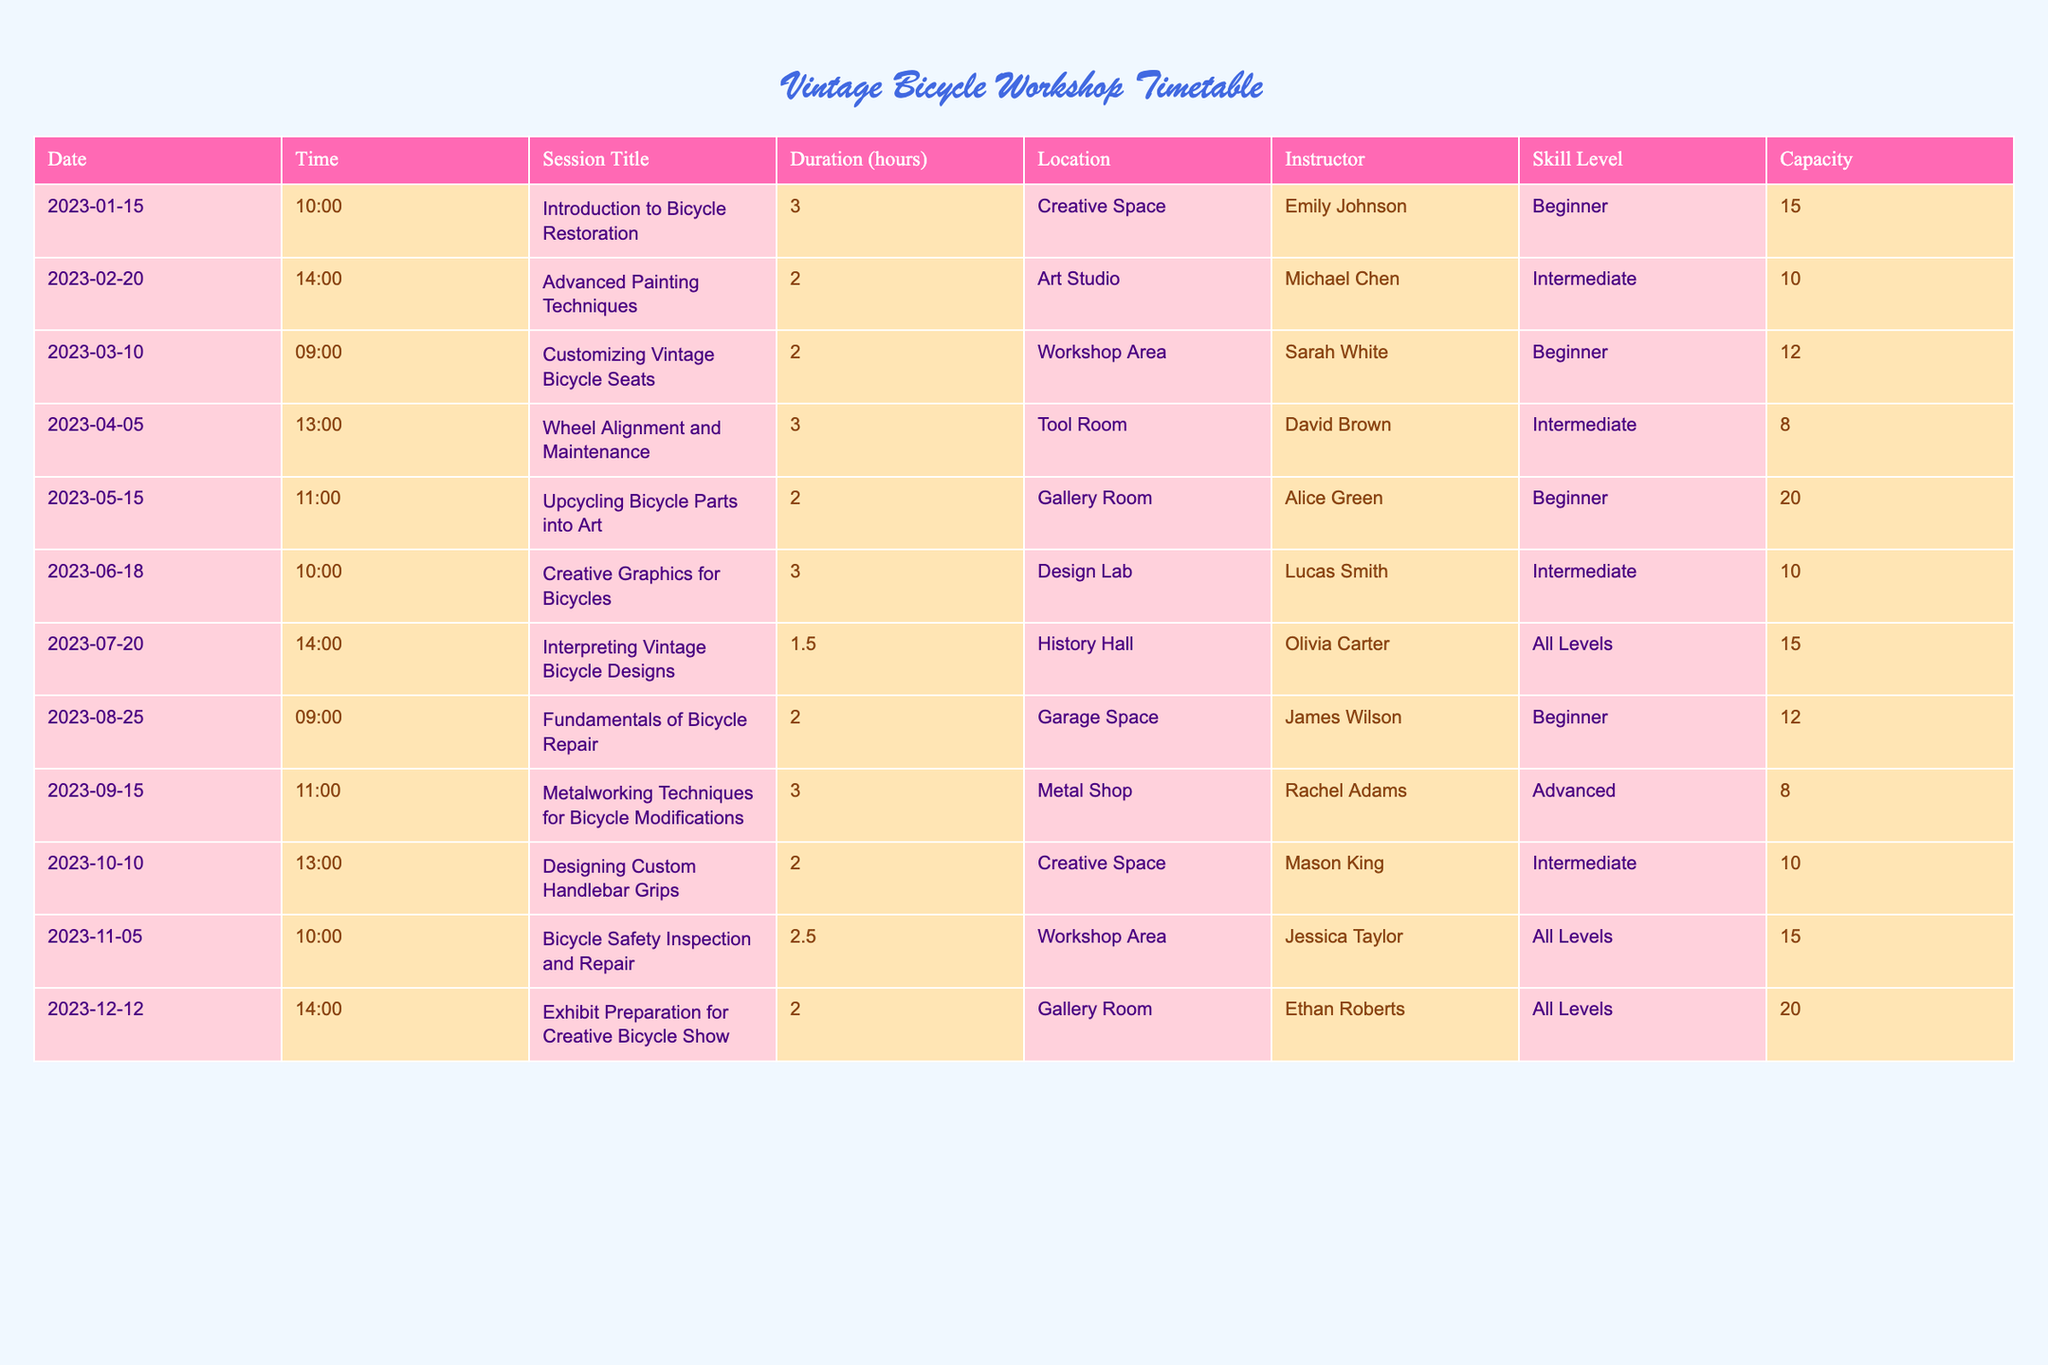What is the duration of the "Customizing Vintage Bicycle Seats" session? The duration of the "Customizing Vintage Bicycle Seats" session is found in the "Duration (hours)" column for the corresponding date and session title. Looking at the table, the duration is 2 hours.
Answer: 2 hours Which session is scheduled for the earliest time? To find the earliest time, we look at the "Time" column for each session. The times listed are 10:00, 14:00, 09:00, etc. The earliest time is 09:00, which corresponds to the "Customizing Vintage Bicycle Seats" session on March 10, 2023.
Answer: 09:00 How many workshops are scheduled for beginners? The workshops for beginners are listed under the "Skill Level" column. By checking this column, we find that there are four sessions labeled as "Beginner": Introduction to Bicycle Restoration, Customizing Vintage Bicycle Seats, Upcycling Bicycle Parts into Art, and Fundamentals of Bicycle Repair. Counting these gives us a total of four workshops.
Answer: 4 What is the total capacity of all sessions scheduled for "All Levels"? First, we identify all the sessions that are listed under "All Levels" from the skill level category. There are three sessions: Interpreting Vintage Bicycle Designs, Bicycle Safety Inspection and Repair, and Exhibit Preparation for Creative Bicycle Show. The capacities for these sessions are 15, 15, and 20 respectively. Summing these capacities gives 15 + 15 + 20 = 50.
Answer: 50 Is there a workshop scheduled that focuses on Advanced techniques? We can answer this by scanning through the "Skill Level" column for the term "Advanced". There is one session, "Metalworking Techniques for Bicycle Modifications," which is labeled as Advanced. Therefore, the answer is yes.
Answer: Yes What is the average duration of the beginner sessions? To calculate the average duration of the beginner sessions, we first identify all the beginner sessions and their durations: Introduction to Bicycle Restoration (3 hours), Customizing Vintage Bicycle Seats (2 hours), Upcycling Bicycle Parts into Art (2 hours), and Fundamentals of Bicycle Repair (2 hours). Next, we sum these durations: 3 + 2 + 2 + 2 = 9. There are 4 sessions, so we divide 9 by 4, giving us an average duration of 2.25 hours.
Answer: 2.25 hours Which instructor has the highest capacity session? To find the highest capacity session, we check the "Capacity" column across the table. The maximum capacity is 20, which corresponds to the "Upcycling Bicycle Parts into Art" and "Exhibit Preparation for Creative Bicycle Show" sessions. Both sessions have the same capacity, but since we're asked for the instructor associated with the highest capacity session, we can choose one: Alice Green from "Upcycling Bicycle Parts into Art".
Answer: Alice Green How many total unique instructors are there across all sessions? To determine the number of unique instructors, we look at the "Instructor" column and identify each instructor mentioned: Emily Johnson, Michael Chen, Sarah White, David Brown, Alice Green, Lucas Smith, Olivia Carter, James Wilson, Rachel Adams, Mason King, and Jessica Taylor. Counting these, we find there are 11 distinct instructors.
Answer: 11 